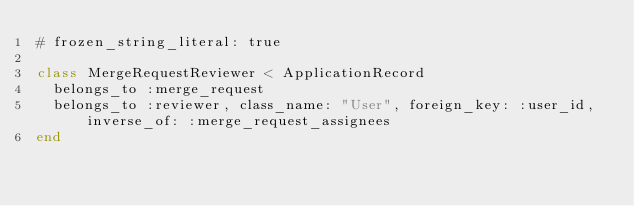Convert code to text. <code><loc_0><loc_0><loc_500><loc_500><_Ruby_># frozen_string_literal: true

class MergeRequestReviewer < ApplicationRecord
  belongs_to :merge_request
  belongs_to :reviewer, class_name: "User", foreign_key: :user_id, inverse_of: :merge_request_assignees
end
</code> 